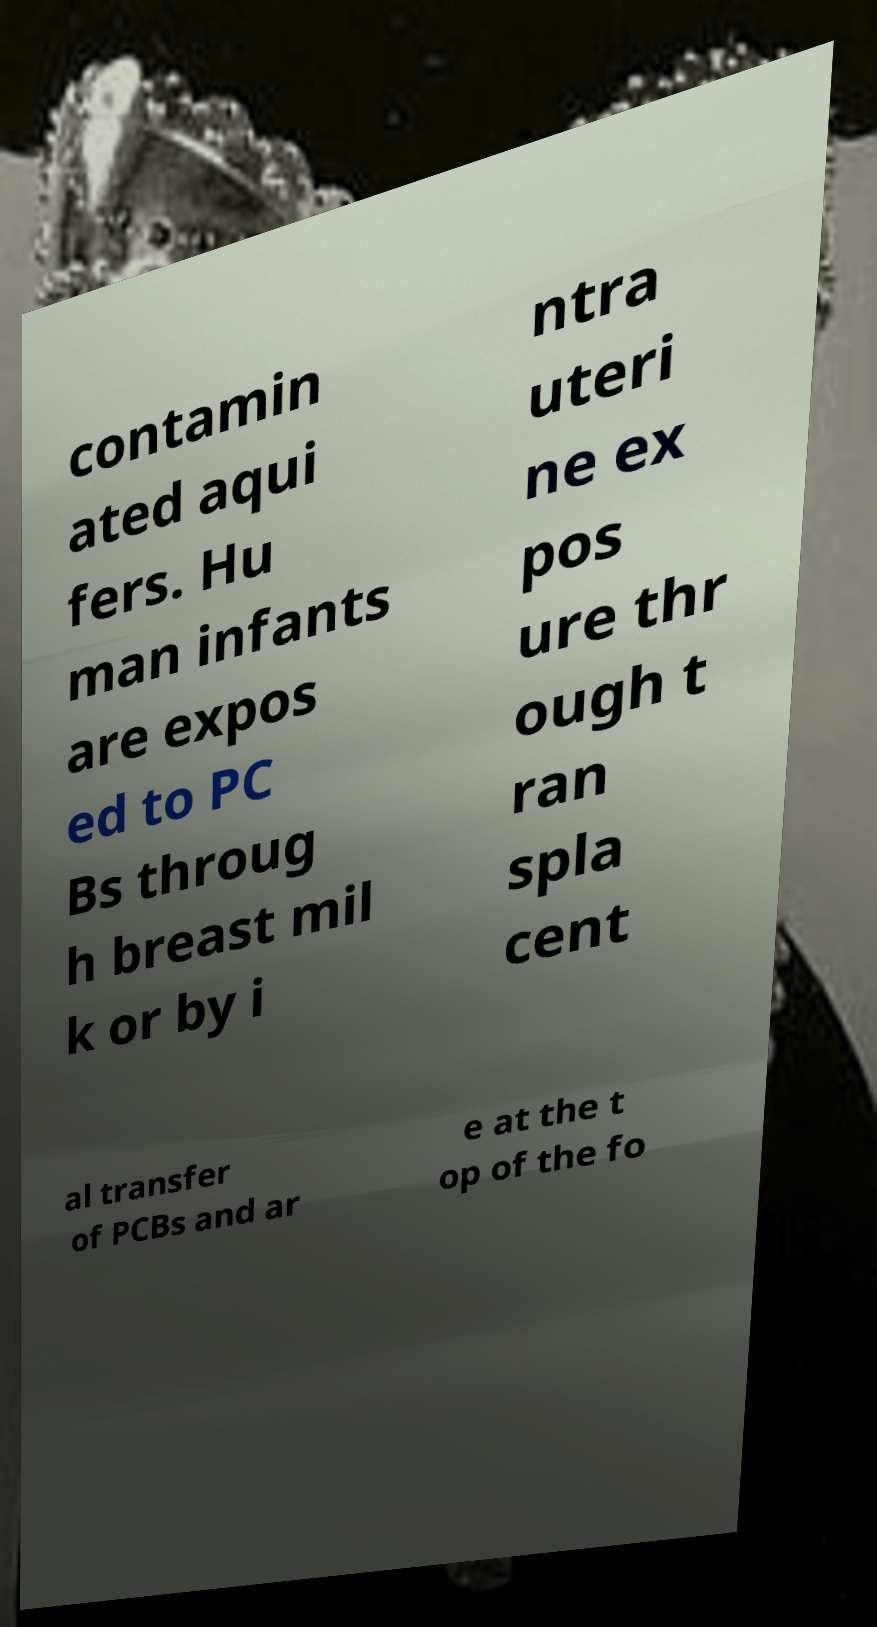Can you read and provide the text displayed in the image?This photo seems to have some interesting text. Can you extract and type it out for me? contamin ated aqui fers. Hu man infants are expos ed to PC Bs throug h breast mil k or by i ntra uteri ne ex pos ure thr ough t ran spla cent al transfer of PCBs and ar e at the t op of the fo 